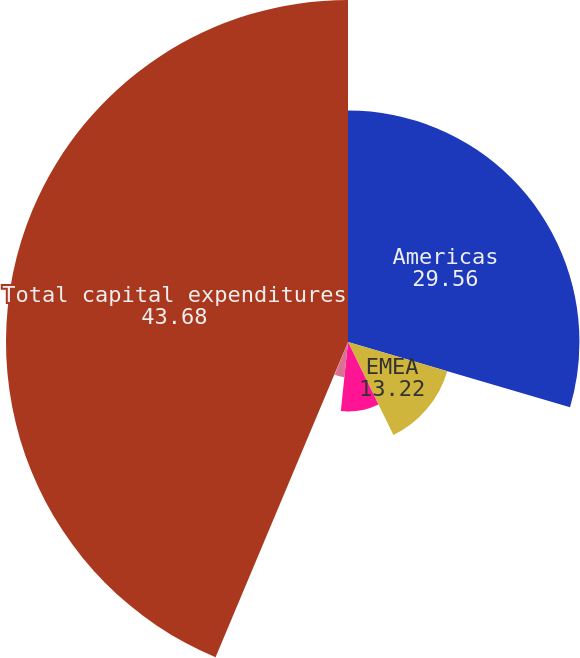Convert chart to OTSL. <chart><loc_0><loc_0><loc_500><loc_500><pie_chart><fcel>Americas<fcel>EMEA<fcel>Asia Pacific<fcel>Global Investment Management<fcel>Development Services<fcel>Total capital expenditures<nl><fcel>29.56%<fcel>13.22%<fcel>8.87%<fcel>4.52%<fcel>0.17%<fcel>43.68%<nl></chart> 